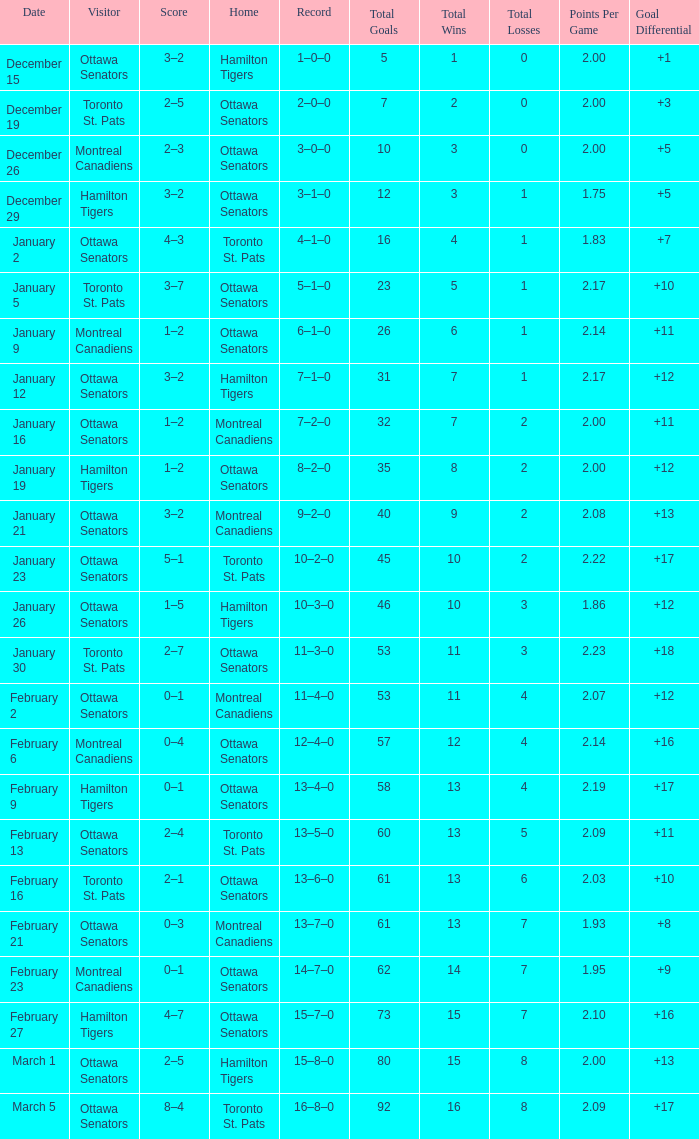Which home team had a visitor of Ottawa Senators with a score of 1–5? Hamilton Tigers. 